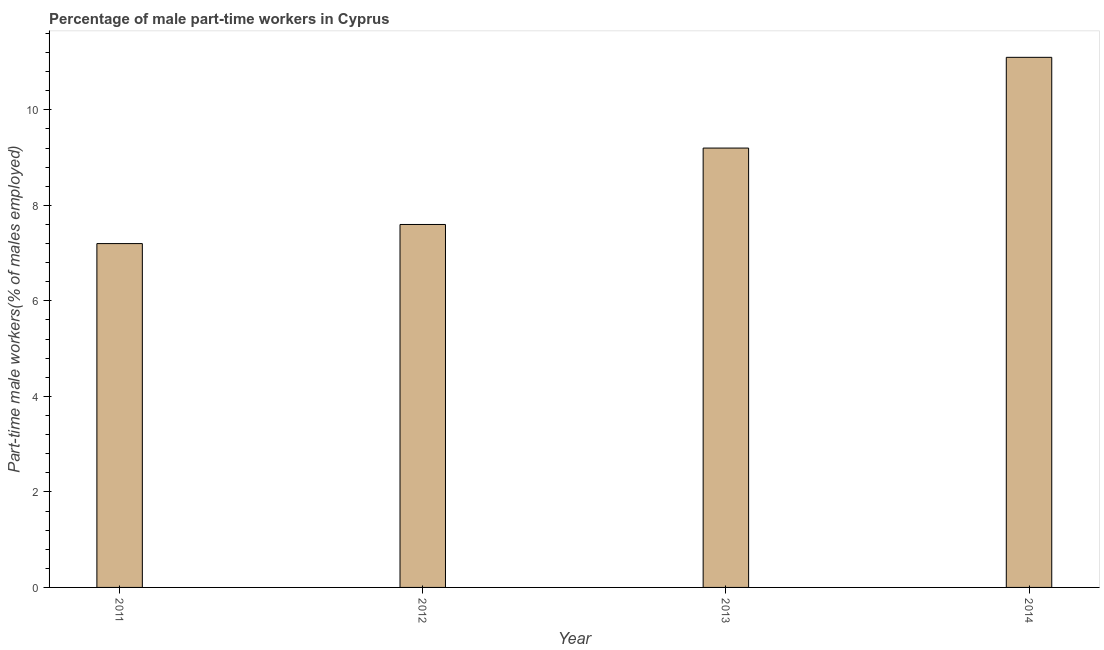Does the graph contain any zero values?
Provide a succinct answer. No. Does the graph contain grids?
Keep it short and to the point. No. What is the title of the graph?
Keep it short and to the point. Percentage of male part-time workers in Cyprus. What is the label or title of the Y-axis?
Ensure brevity in your answer.  Part-time male workers(% of males employed). What is the percentage of part-time male workers in 2013?
Your answer should be compact. 9.2. Across all years, what is the maximum percentage of part-time male workers?
Provide a succinct answer. 11.1. Across all years, what is the minimum percentage of part-time male workers?
Make the answer very short. 7.2. In which year was the percentage of part-time male workers minimum?
Your response must be concise. 2011. What is the sum of the percentage of part-time male workers?
Ensure brevity in your answer.  35.1. What is the average percentage of part-time male workers per year?
Your response must be concise. 8.78. What is the median percentage of part-time male workers?
Provide a succinct answer. 8.4. In how many years, is the percentage of part-time male workers greater than 4.8 %?
Provide a short and direct response. 4. What is the ratio of the percentage of part-time male workers in 2011 to that in 2012?
Your answer should be very brief. 0.95. Is the difference between the percentage of part-time male workers in 2013 and 2014 greater than the difference between any two years?
Offer a very short reply. No. What is the difference between the highest and the lowest percentage of part-time male workers?
Your answer should be very brief. 3.9. How many bars are there?
Your answer should be very brief. 4. How many years are there in the graph?
Keep it short and to the point. 4. What is the difference between two consecutive major ticks on the Y-axis?
Give a very brief answer. 2. Are the values on the major ticks of Y-axis written in scientific E-notation?
Ensure brevity in your answer.  No. What is the Part-time male workers(% of males employed) in 2011?
Give a very brief answer. 7.2. What is the Part-time male workers(% of males employed) of 2012?
Make the answer very short. 7.6. What is the Part-time male workers(% of males employed) of 2013?
Offer a terse response. 9.2. What is the Part-time male workers(% of males employed) in 2014?
Your answer should be compact. 11.1. What is the difference between the Part-time male workers(% of males employed) in 2011 and 2012?
Provide a succinct answer. -0.4. What is the difference between the Part-time male workers(% of males employed) in 2011 and 2013?
Offer a terse response. -2. What is the difference between the Part-time male workers(% of males employed) in 2012 and 2013?
Provide a succinct answer. -1.6. What is the difference between the Part-time male workers(% of males employed) in 2012 and 2014?
Your answer should be very brief. -3.5. What is the ratio of the Part-time male workers(% of males employed) in 2011 to that in 2012?
Offer a terse response. 0.95. What is the ratio of the Part-time male workers(% of males employed) in 2011 to that in 2013?
Your response must be concise. 0.78. What is the ratio of the Part-time male workers(% of males employed) in 2011 to that in 2014?
Your answer should be very brief. 0.65. What is the ratio of the Part-time male workers(% of males employed) in 2012 to that in 2013?
Your answer should be very brief. 0.83. What is the ratio of the Part-time male workers(% of males employed) in 2012 to that in 2014?
Offer a very short reply. 0.69. What is the ratio of the Part-time male workers(% of males employed) in 2013 to that in 2014?
Make the answer very short. 0.83. 